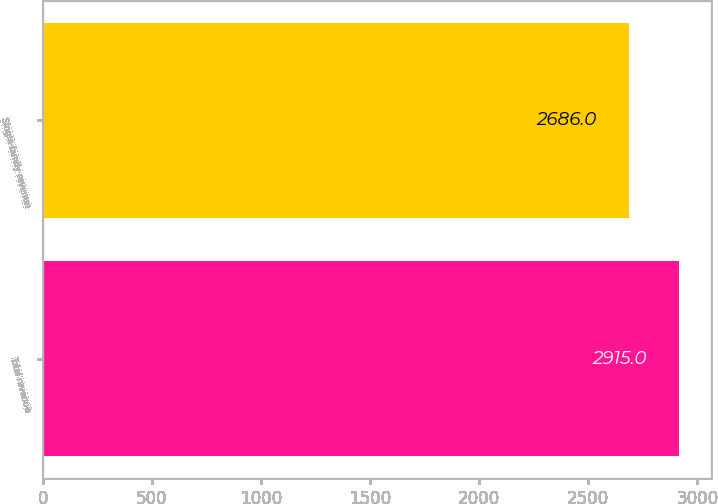<chart> <loc_0><loc_0><loc_500><loc_500><bar_chart><fcel>Total revenue<fcel>Single-family revenue<nl><fcel>2915<fcel>2686<nl></chart> 